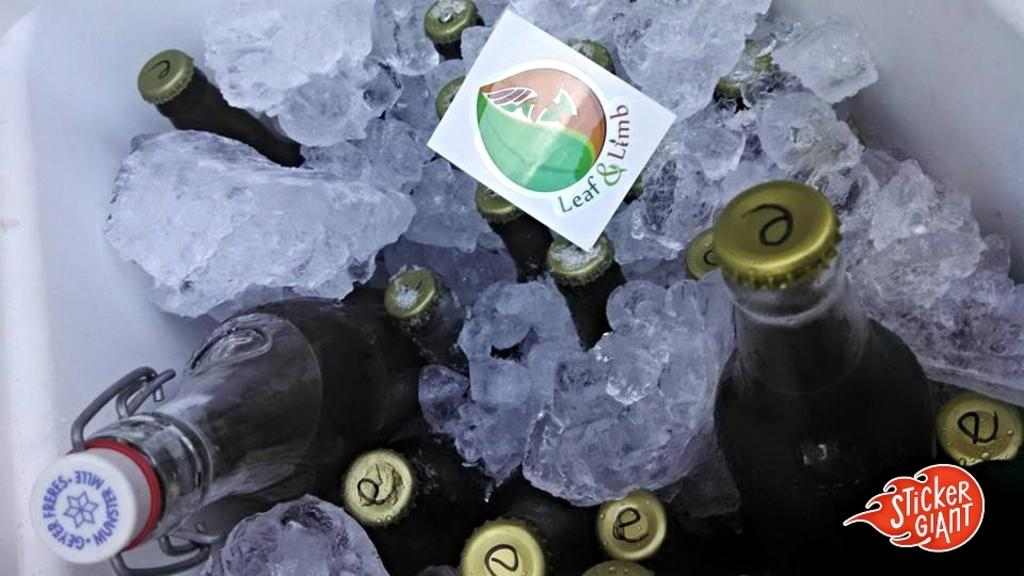Provide a one-sentence caption for the provided image. An inside of a cooler with ice and drinks and a note with the words leaf and limb. 